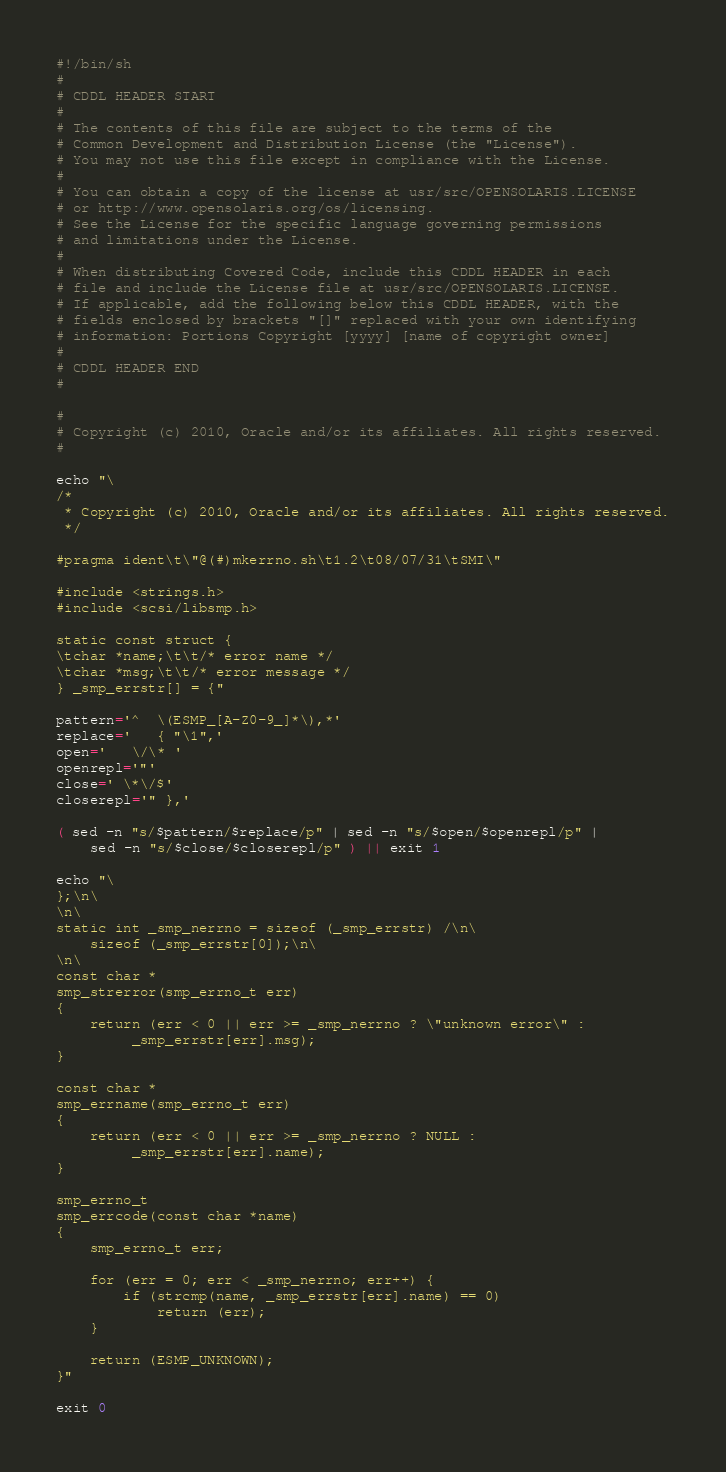<code> <loc_0><loc_0><loc_500><loc_500><_Bash_>#!/bin/sh
#
# CDDL HEADER START
#
# The contents of this file are subject to the terms of the
# Common Development and Distribution License (the "License").
# You may not use this file except in compliance with the License.
#
# You can obtain a copy of the license at usr/src/OPENSOLARIS.LICENSE
# or http://www.opensolaris.org/os/licensing.
# See the License for the specific language governing permissions
# and limitations under the License.
#
# When distributing Covered Code, include this CDDL HEADER in each
# file and include the License file at usr/src/OPENSOLARIS.LICENSE.
# If applicable, add the following below this CDDL HEADER, with the
# fields enclosed by brackets "[]" replaced with your own identifying
# information: Portions Copyright [yyyy] [name of copyright owner]
#
# CDDL HEADER END
#

#
# Copyright (c) 2010, Oracle and/or its affiliates. All rights reserved.
#

echo "\
/*
 * Copyright (c) 2010, Oracle and/or its affiliates. All rights reserved.
 */

#pragma ident\t\"@(#)mkerrno.sh\t1.2\t08/07/31\tSMI\"

#include <strings.h>
#include <scsi/libsmp.h>

static const struct {
\tchar *name;\t\t/* error name */
\tchar *msg;\t\t/* error message */
} _smp_errstr[] = {"

pattern='^	\(ESMP_[A-Z0-9_]*\),*'
replace='	{ "\1",'
open='	\/\* '
openrepl='"'
close=' \*\/$'
closerepl='" },'

( sed -n "s/$pattern/$replace/p" | sed -n "s/$open/$openrepl/p" |
    sed -n "s/$close/$closerepl/p" ) || exit 1

echo "\
};\n\
\n\
static int _smp_nerrno = sizeof (_smp_errstr) /\n\
    sizeof (_smp_errstr[0]);\n\
\n\
const char *
smp_strerror(smp_errno_t err)
{
	return (err < 0 || err >= _smp_nerrno ? \"unknown error\" :
	     _smp_errstr[err].msg);
}

const char *
smp_errname(smp_errno_t err)
{
	return (err < 0 || err >= _smp_nerrno ? NULL :
	     _smp_errstr[err].name);
}

smp_errno_t
smp_errcode(const char *name)
{
	smp_errno_t err;

	for (err = 0; err < _smp_nerrno; err++) {
		if (strcmp(name, _smp_errstr[err].name) == 0)
			return (err);
	}

	return (ESMP_UNKNOWN);
}"

exit 0
</code> 